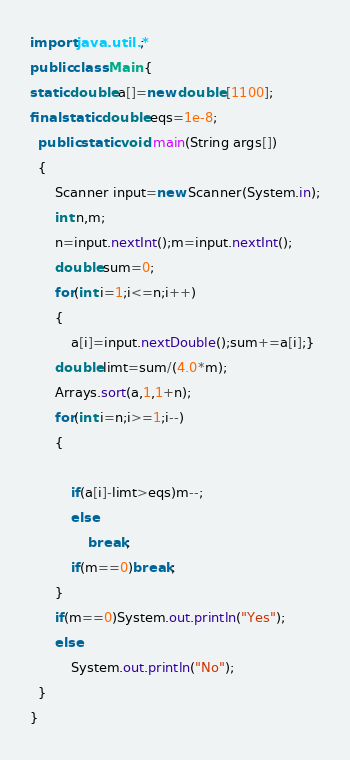Convert code to text. <code><loc_0><loc_0><loc_500><loc_500><_Java_>import java.util.*;
public class Main {
static double a[]=new double [1100];
final static double eqs=1e-8;
  public static void main(String args[])
  {
	  Scanner input=new Scanner(System.in);
	  int n,m;
	  n=input.nextInt();m=input.nextInt();
	  double sum=0;
	  for(int i=1;i<=n;i++)
	  {
		  a[i]=input.nextDouble();sum+=a[i];}
	  double limt=sum/(4.0*m);
	  Arrays.sort(a,1,1+n);
	  for(int i=n;i>=1;i--)
	  {
		  
		  if(a[i]-limt>eqs)m--;
		  else
			  break;
		  if(m==0)break;
	  }
	  if(m==0)System.out.println("Yes");
	  else
		  System.out.println("No");
  }
}</code> 